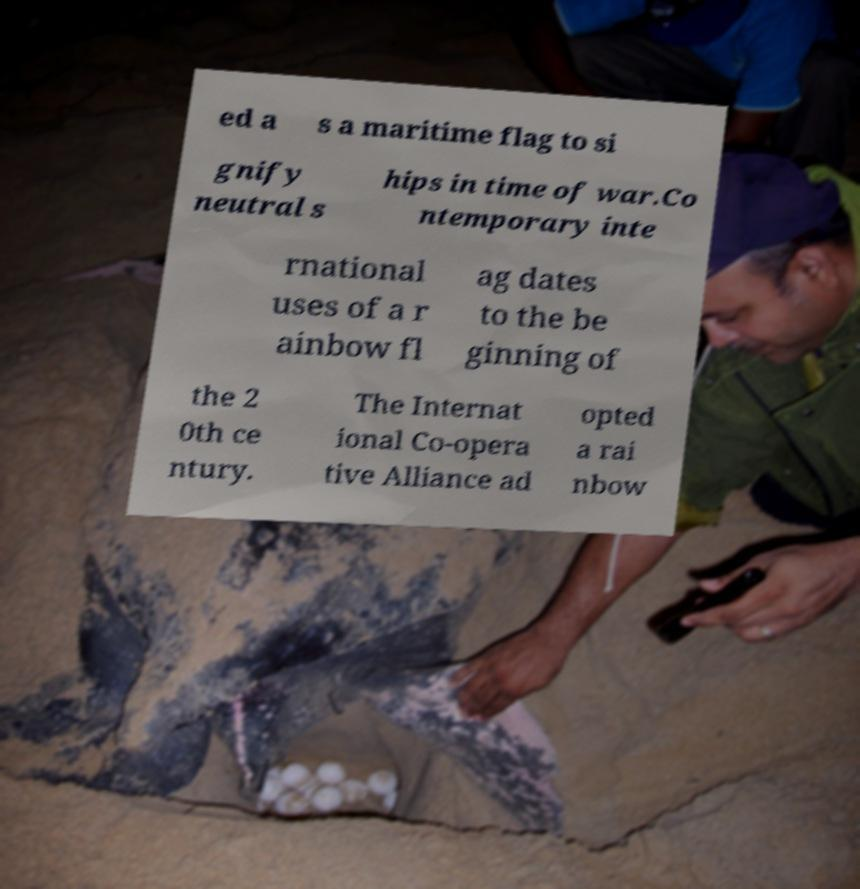There's text embedded in this image that I need extracted. Can you transcribe it verbatim? ed a s a maritime flag to si gnify neutral s hips in time of war.Co ntemporary inte rnational uses of a r ainbow fl ag dates to the be ginning of the 2 0th ce ntury. The Internat ional Co-opera tive Alliance ad opted a rai nbow 